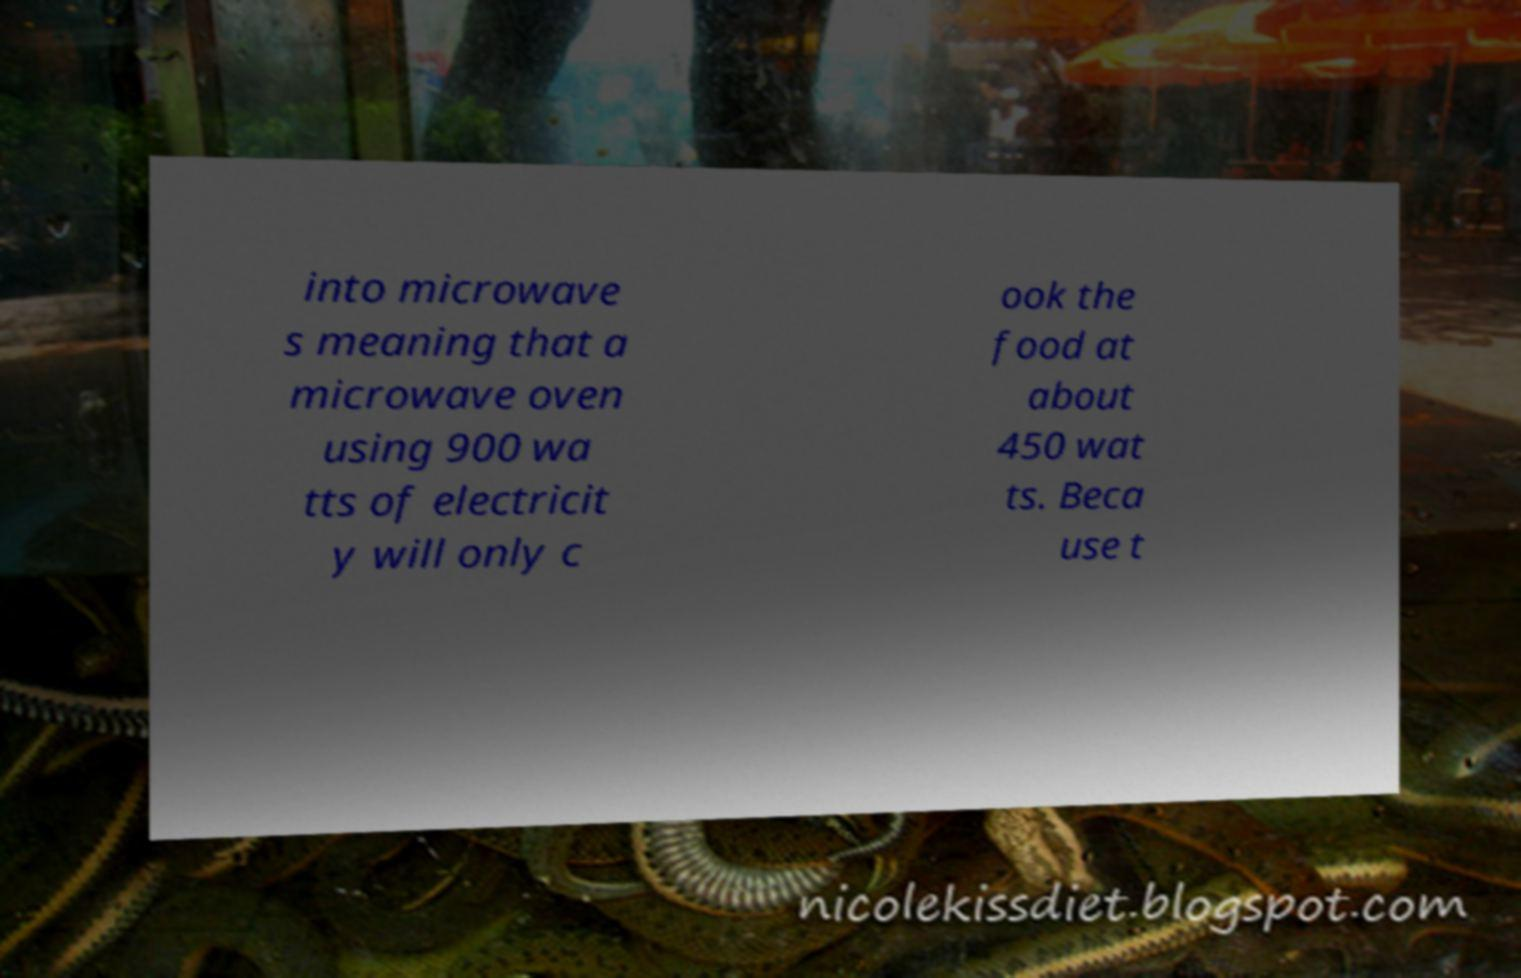For documentation purposes, I need the text within this image transcribed. Could you provide that? into microwave s meaning that a microwave oven using 900 wa tts of electricit y will only c ook the food at about 450 wat ts. Beca use t 